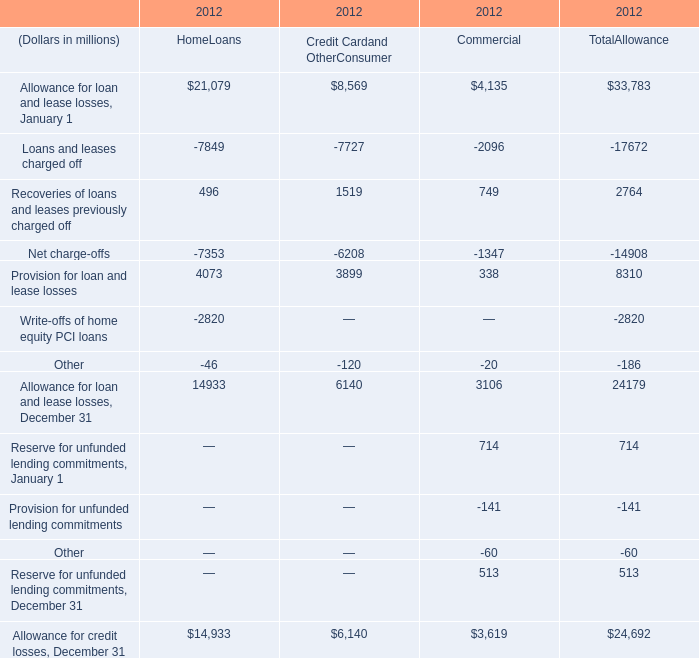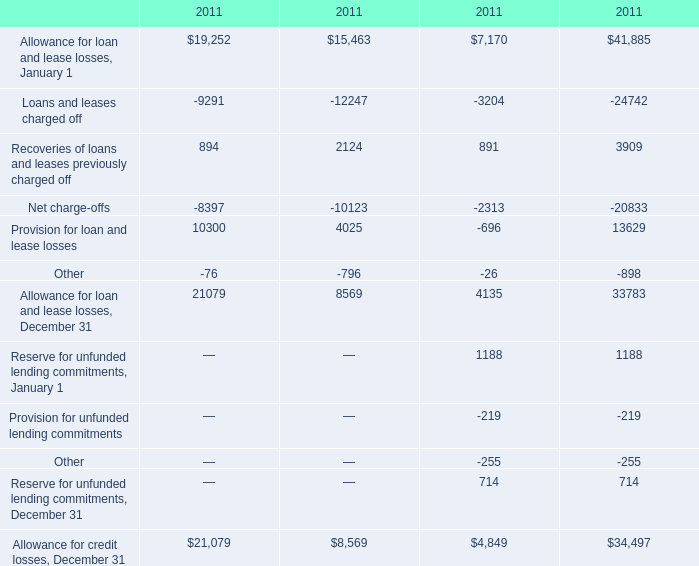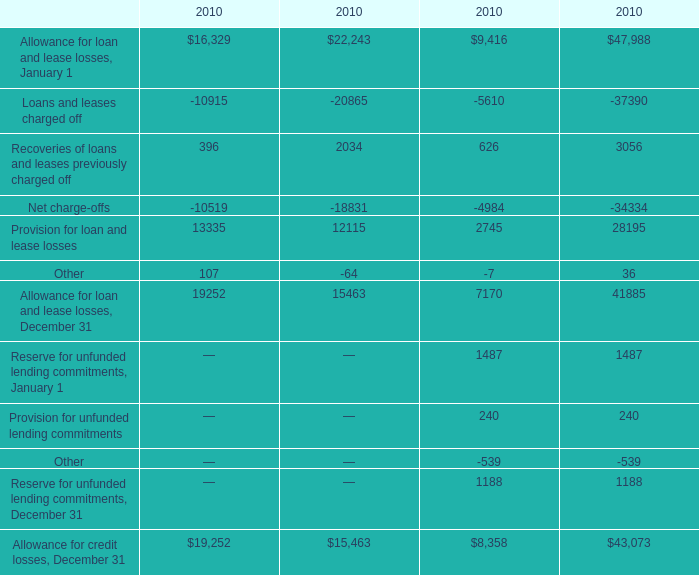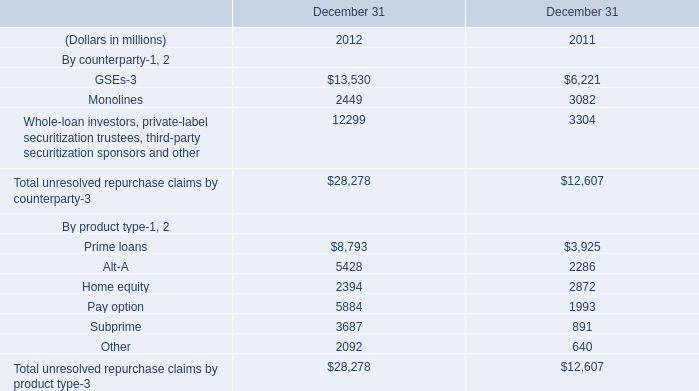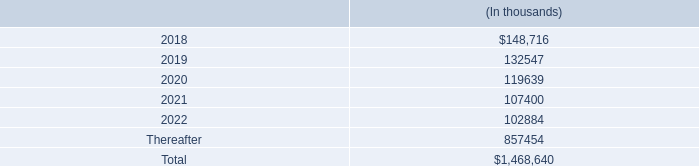What's the average of Provision for loan and lease losses in 2011? 
Computations: ((((10300 + 4025) + 13629) - 696) / 4)
Answer: 6814.5. 